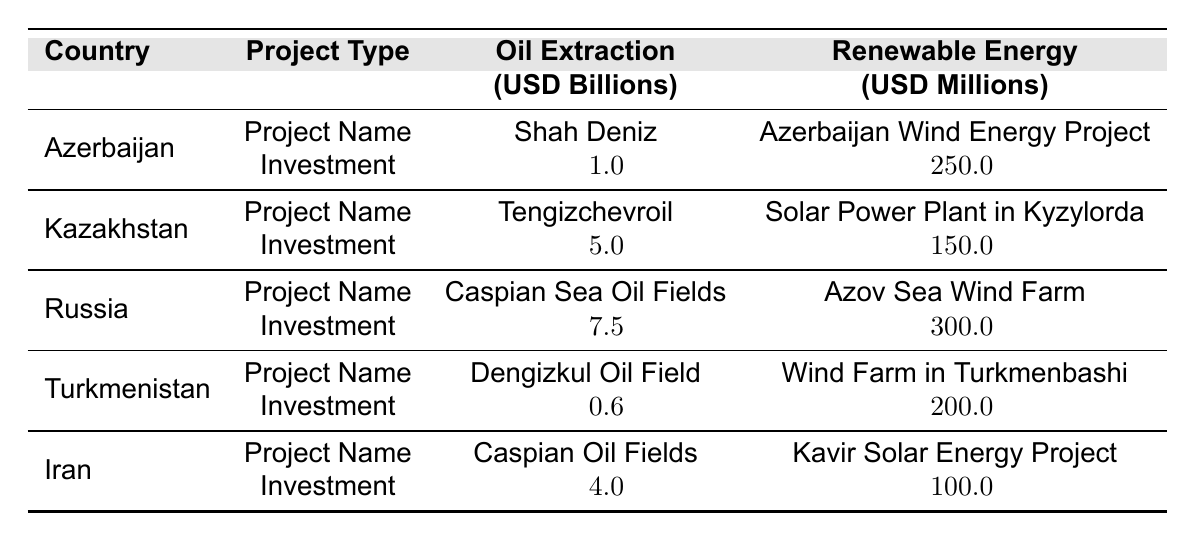What is the total investment in oil extraction projects in Azerbaijan? The investment amount for oil extraction in Azerbaijan is listed as 1.0 billion USD for the Shah Deniz project. Therefore, the total investment is 1 billion USD.
Answer: 1 billion USD What is the combined investment in renewable energy projects across all countries? The investments in renewable energy projects are 250 million for Azerbaijan, 150 million for Kazakhstan, 300 million for Russia, 200 million for Turkmenistan, and 100 million for Iran. Adding these together: 250 + 150 + 300 + 200 + 100 = 1000 million USD (or 1 billion USD).
Answer: 1 billion USD How much higher is the investment in oil extraction in Russia compared to Turkmenistan? The oil extraction investment in Russia is 7.5 billion USD, and for Turkmenistan, it is 0.6 billion USD. The difference is 7.5 - 0.6 = 6.9 billion USD.
Answer: 6.9 billion USD Which country has the highest investment in renewable energy, and what is the amount? Looking at the renewable energy investments, Russia has the highest amount at 300 million USD for the Azov Sea Wind Farm project.
Answer: Russia, 300 million USD Is there any country that invests in both oil extraction and renewable energy projects? Yes, all the listed countries (Azerbaijan, Kazakhstan, Russia, Turkmenistan, Iran) invest in both oil extraction and renewable energy projects.
Answer: Yes What is the average investment amount for oil extraction projects in the Caspian Sea? The investments for oil extraction are 1.0 billion (Azerbaijan), 5.0 billion (Kazakhstan), 7.5 billion (Russia), 0.6 billion (Turkmenistan), and 4.0 billion (Iran). The average is: (1.0 + 5.0 + 7.5 + 0.6 + 4.0) / 5 = 18.1 / 5 = 3.62 billion USD.
Answer: 3.62 billion USD How much lower is the investment in renewable energy in Kazakhstan compared to that in Russia? The investment in renewable energy in Kazakhstan is 150 million USD, and in Russia, it is 300 million USD. The difference is 300 - 150 = 150 million USD; hence Kazakhstan's investment is 150 million lower.
Answer: 150 million USD What proportion of the total investments in renewable energy comes from Azerbaijan? The total renewable energy investment is 1 billion USD (or 1000 million), and Azerbaijan's investment is 250 million USD. The proportion is 250 / 1000 = 0.25 or 25%.
Answer: 25% Which country has the least investment in renewable energy, and what is the amount? Reviewing the renewable energy investments, Iran has the least investment at 100 million USD for the Kavir Solar Energy Project.
Answer: Iran, 100 million USD What is the total investment amount for oil extraction projects across all listed countries? The total for oil extraction is from Azerbaijan (1.0 billion), Kazakhstan (5.0 billion), Russia (7.5 billion), Turkmenistan (0.6 billion), and Iran (4.0 billion). Adding these amounts yields 1 + 5 + 7.5 + 0.6 + 4 = 18.1 billion USD.
Answer: 18.1 billion USD 